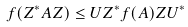<formula> <loc_0><loc_0><loc_500><loc_500>f ( Z ^ { * } A Z ) \leq U Z ^ { * } f ( A ) Z U ^ { * }</formula> 